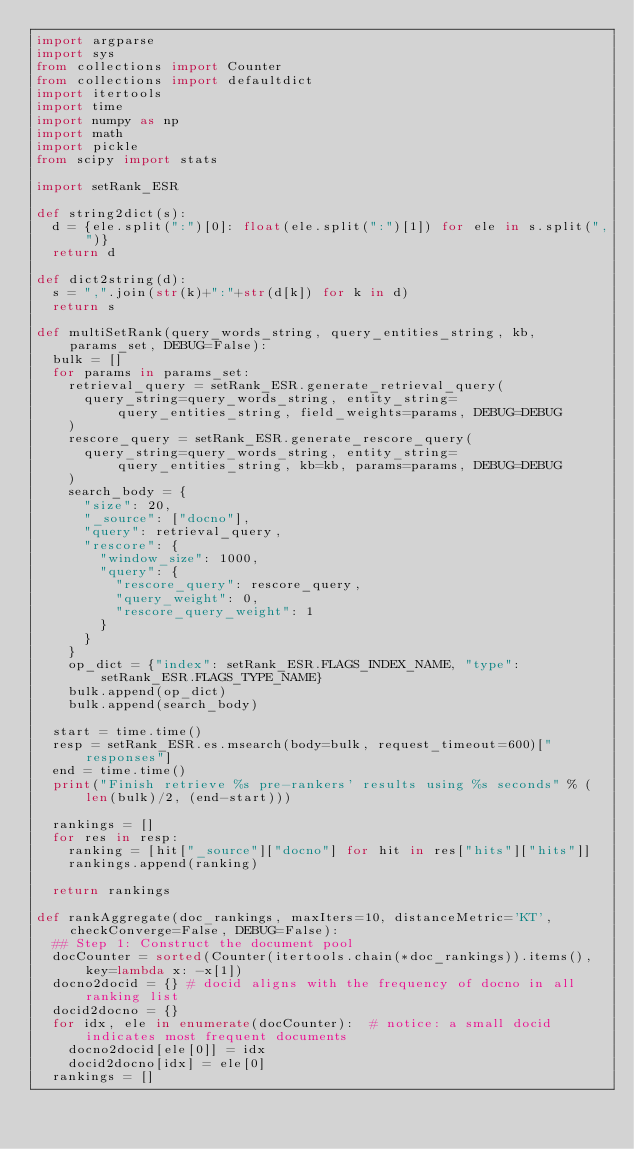<code> <loc_0><loc_0><loc_500><loc_500><_Python_>import argparse
import sys
from collections import Counter
from collections import defaultdict
import itertools
import time
import numpy as np
import math
import pickle
from scipy import stats

import setRank_ESR

def string2dict(s):
  d = {ele.split(":")[0]: float(ele.split(":")[1]) for ele in s.split(",")}
  return d

def dict2string(d):
  s = ",".join(str(k)+":"+str(d[k]) for k in d)
  return s

def multiSetRank(query_words_string, query_entities_string, kb, params_set, DEBUG=False):
  bulk = []
  for params in params_set:
    retrieval_query = setRank_ESR.generate_retrieval_query(
      query_string=query_words_string, entity_string=query_entities_string, field_weights=params, DEBUG=DEBUG
    )
    rescore_query = setRank_ESR.generate_rescore_query(
      query_string=query_words_string, entity_string=query_entities_string, kb=kb, params=params, DEBUG=DEBUG
    )
    search_body = {
      "size": 20,
      "_source": ["docno"],
      "query": retrieval_query,
      "rescore": {
        "window_size": 1000,
        "query": {
          "rescore_query": rescore_query,
          "query_weight": 0,
          "rescore_query_weight": 1
        }
      }
    }
    op_dict = {"index": setRank_ESR.FLAGS_INDEX_NAME, "type": setRank_ESR.FLAGS_TYPE_NAME}
    bulk.append(op_dict)
    bulk.append(search_body)

  start = time.time()
  resp = setRank_ESR.es.msearch(body=bulk, request_timeout=600)["responses"]
  end = time.time()
  print("Finish retrieve %s pre-rankers' results using %s seconds" % (len(bulk)/2, (end-start)))

  rankings = []
  for res in resp:
    ranking = [hit["_source"]["docno"] for hit in res["hits"]["hits"]]
    rankings.append(ranking)

  return rankings

def rankAggregate(doc_rankings, maxIters=10, distanceMetric='KT', checkConverge=False, DEBUG=False):
  ## Step 1: Construct the document pool
  docCounter = sorted(Counter(itertools.chain(*doc_rankings)).items(), key=lambda x: -x[1])
  docno2docid = {} # docid aligns with the frequency of docno in all ranking list
  docid2docno = {}
  for idx, ele in enumerate(docCounter):  # notice: a small docid indicates most frequent documents
    docno2docid[ele[0]] = idx
    docid2docno[idx] = ele[0]
  rankings = []</code> 